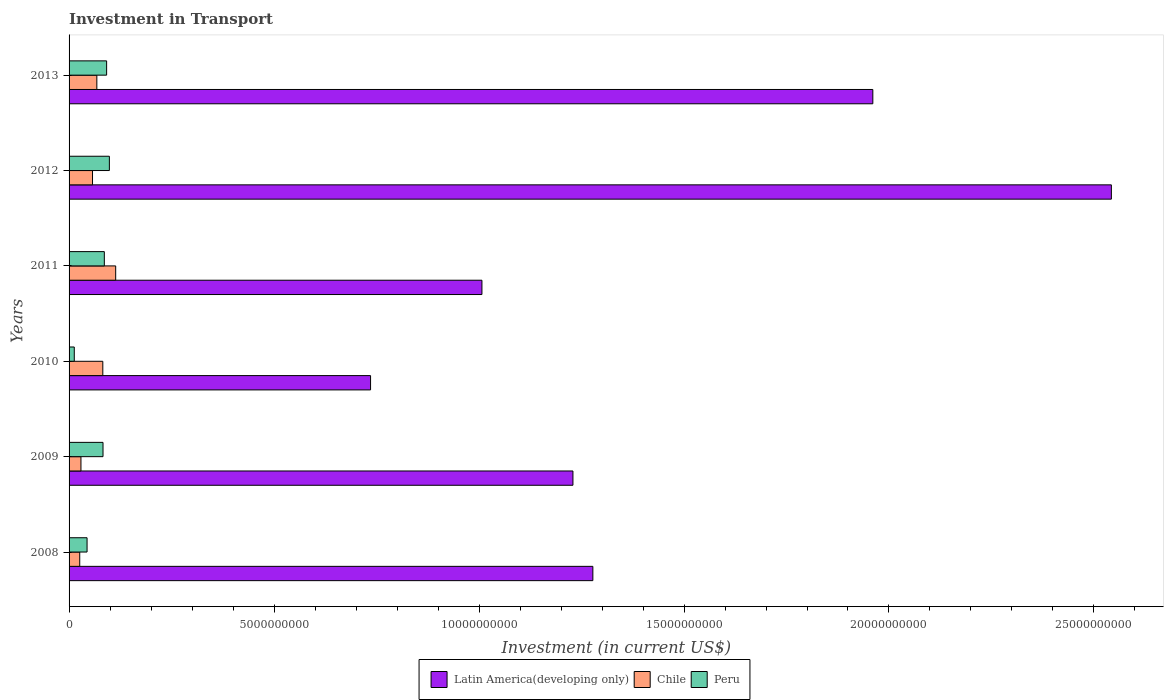How many different coloured bars are there?
Your response must be concise. 3. What is the label of the 4th group of bars from the top?
Your answer should be very brief. 2010. In how many cases, is the number of bars for a given year not equal to the number of legend labels?
Give a very brief answer. 0. What is the amount invested in transport in Peru in 2011?
Your answer should be very brief. 8.60e+08. Across all years, what is the maximum amount invested in transport in Latin America(developing only)?
Ensure brevity in your answer.  2.54e+1. Across all years, what is the minimum amount invested in transport in Latin America(developing only)?
Give a very brief answer. 7.35e+09. In which year was the amount invested in transport in Chile maximum?
Provide a short and direct response. 2011. What is the total amount invested in transport in Peru in the graph?
Your answer should be very brief. 4.15e+09. What is the difference between the amount invested in transport in Latin America(developing only) in 2010 and that in 2012?
Your answer should be very brief. -1.81e+1. What is the difference between the amount invested in transport in Latin America(developing only) in 2009 and the amount invested in transport in Chile in 2012?
Your answer should be compact. 1.17e+1. What is the average amount invested in transport in Latin America(developing only) per year?
Keep it short and to the point. 1.46e+1. In the year 2013, what is the difference between the amount invested in transport in Chile and amount invested in transport in Latin America(developing only)?
Your answer should be very brief. -1.89e+1. In how many years, is the amount invested in transport in Peru greater than 21000000000 US$?
Ensure brevity in your answer.  0. What is the ratio of the amount invested in transport in Peru in 2011 to that in 2012?
Your answer should be very brief. 0.87. Is the difference between the amount invested in transport in Chile in 2012 and 2013 greater than the difference between the amount invested in transport in Latin America(developing only) in 2012 and 2013?
Offer a terse response. No. What is the difference between the highest and the second highest amount invested in transport in Chile?
Your answer should be compact. 3.14e+08. What is the difference between the highest and the lowest amount invested in transport in Peru?
Your answer should be compact. 8.56e+08. In how many years, is the amount invested in transport in Peru greater than the average amount invested in transport in Peru taken over all years?
Your answer should be very brief. 4. Is the sum of the amount invested in transport in Latin America(developing only) in 2011 and 2013 greater than the maximum amount invested in transport in Peru across all years?
Provide a short and direct response. Yes. What does the 2nd bar from the bottom in 2011 represents?
Keep it short and to the point. Chile. How many bars are there?
Your answer should be very brief. 18. What is the difference between two consecutive major ticks on the X-axis?
Your answer should be compact. 5.00e+09. Where does the legend appear in the graph?
Provide a succinct answer. Bottom center. How many legend labels are there?
Ensure brevity in your answer.  3. How are the legend labels stacked?
Keep it short and to the point. Horizontal. What is the title of the graph?
Your answer should be compact. Investment in Transport. What is the label or title of the X-axis?
Offer a very short reply. Investment (in current US$). What is the label or title of the Y-axis?
Offer a very short reply. Years. What is the Investment (in current US$) in Latin America(developing only) in 2008?
Your answer should be very brief. 1.28e+1. What is the Investment (in current US$) of Chile in 2008?
Give a very brief answer. 2.60e+08. What is the Investment (in current US$) in Peru in 2008?
Ensure brevity in your answer.  4.39e+08. What is the Investment (in current US$) of Latin America(developing only) in 2009?
Your answer should be very brief. 1.23e+1. What is the Investment (in current US$) of Chile in 2009?
Ensure brevity in your answer.  2.90e+08. What is the Investment (in current US$) in Peru in 2009?
Provide a short and direct response. 8.28e+08. What is the Investment (in current US$) in Latin America(developing only) in 2010?
Offer a very short reply. 7.35e+09. What is the Investment (in current US$) of Chile in 2010?
Give a very brief answer. 8.23e+08. What is the Investment (in current US$) of Peru in 2010?
Make the answer very short. 1.27e+08. What is the Investment (in current US$) in Latin America(developing only) in 2011?
Provide a short and direct response. 1.01e+1. What is the Investment (in current US$) in Chile in 2011?
Ensure brevity in your answer.  1.14e+09. What is the Investment (in current US$) of Peru in 2011?
Give a very brief answer. 8.60e+08. What is the Investment (in current US$) of Latin America(developing only) in 2012?
Make the answer very short. 2.54e+1. What is the Investment (in current US$) of Chile in 2012?
Your response must be concise. 5.72e+08. What is the Investment (in current US$) in Peru in 2012?
Ensure brevity in your answer.  9.83e+08. What is the Investment (in current US$) of Latin America(developing only) in 2013?
Offer a very short reply. 1.96e+1. What is the Investment (in current US$) of Chile in 2013?
Your answer should be very brief. 6.78e+08. What is the Investment (in current US$) of Peru in 2013?
Your response must be concise. 9.16e+08. Across all years, what is the maximum Investment (in current US$) in Latin America(developing only)?
Your answer should be very brief. 2.54e+1. Across all years, what is the maximum Investment (in current US$) of Chile?
Provide a short and direct response. 1.14e+09. Across all years, what is the maximum Investment (in current US$) in Peru?
Make the answer very short. 9.83e+08. Across all years, what is the minimum Investment (in current US$) of Latin America(developing only)?
Keep it short and to the point. 7.35e+09. Across all years, what is the minimum Investment (in current US$) in Chile?
Make the answer very short. 2.60e+08. Across all years, what is the minimum Investment (in current US$) of Peru?
Give a very brief answer. 1.27e+08. What is the total Investment (in current US$) of Latin America(developing only) in the graph?
Provide a short and direct response. 8.75e+1. What is the total Investment (in current US$) in Chile in the graph?
Give a very brief answer. 3.76e+09. What is the total Investment (in current US$) of Peru in the graph?
Provide a short and direct response. 4.15e+09. What is the difference between the Investment (in current US$) of Latin America(developing only) in 2008 and that in 2009?
Provide a succinct answer. 4.86e+08. What is the difference between the Investment (in current US$) of Chile in 2008 and that in 2009?
Make the answer very short. -2.99e+07. What is the difference between the Investment (in current US$) of Peru in 2008 and that in 2009?
Your answer should be compact. -3.89e+08. What is the difference between the Investment (in current US$) of Latin America(developing only) in 2008 and that in 2010?
Make the answer very short. 5.42e+09. What is the difference between the Investment (in current US$) of Chile in 2008 and that in 2010?
Your answer should be very brief. -5.63e+08. What is the difference between the Investment (in current US$) in Peru in 2008 and that in 2010?
Provide a short and direct response. 3.12e+08. What is the difference between the Investment (in current US$) in Latin America(developing only) in 2008 and that in 2011?
Ensure brevity in your answer.  2.71e+09. What is the difference between the Investment (in current US$) in Chile in 2008 and that in 2011?
Keep it short and to the point. -8.77e+08. What is the difference between the Investment (in current US$) of Peru in 2008 and that in 2011?
Your response must be concise. -4.21e+08. What is the difference between the Investment (in current US$) in Latin America(developing only) in 2008 and that in 2012?
Make the answer very short. -1.26e+1. What is the difference between the Investment (in current US$) of Chile in 2008 and that in 2012?
Give a very brief answer. -3.12e+08. What is the difference between the Investment (in current US$) of Peru in 2008 and that in 2012?
Ensure brevity in your answer.  -5.44e+08. What is the difference between the Investment (in current US$) in Latin America(developing only) in 2008 and that in 2013?
Your response must be concise. -6.83e+09. What is the difference between the Investment (in current US$) in Chile in 2008 and that in 2013?
Offer a terse response. -4.18e+08. What is the difference between the Investment (in current US$) of Peru in 2008 and that in 2013?
Ensure brevity in your answer.  -4.77e+08. What is the difference between the Investment (in current US$) of Latin America(developing only) in 2009 and that in 2010?
Make the answer very short. 4.94e+09. What is the difference between the Investment (in current US$) of Chile in 2009 and that in 2010?
Ensure brevity in your answer.  -5.33e+08. What is the difference between the Investment (in current US$) of Peru in 2009 and that in 2010?
Offer a very short reply. 7.01e+08. What is the difference between the Investment (in current US$) of Latin America(developing only) in 2009 and that in 2011?
Your response must be concise. 2.22e+09. What is the difference between the Investment (in current US$) of Chile in 2009 and that in 2011?
Provide a short and direct response. -8.47e+08. What is the difference between the Investment (in current US$) of Peru in 2009 and that in 2011?
Keep it short and to the point. -3.22e+07. What is the difference between the Investment (in current US$) in Latin America(developing only) in 2009 and that in 2012?
Make the answer very short. -1.31e+1. What is the difference between the Investment (in current US$) of Chile in 2009 and that in 2012?
Offer a very short reply. -2.82e+08. What is the difference between the Investment (in current US$) of Peru in 2009 and that in 2012?
Offer a very short reply. -1.55e+08. What is the difference between the Investment (in current US$) in Latin America(developing only) in 2009 and that in 2013?
Keep it short and to the point. -7.32e+09. What is the difference between the Investment (in current US$) of Chile in 2009 and that in 2013?
Give a very brief answer. -3.88e+08. What is the difference between the Investment (in current US$) in Peru in 2009 and that in 2013?
Ensure brevity in your answer.  -8.82e+07. What is the difference between the Investment (in current US$) in Latin America(developing only) in 2010 and that in 2011?
Provide a short and direct response. -2.72e+09. What is the difference between the Investment (in current US$) of Chile in 2010 and that in 2011?
Give a very brief answer. -3.14e+08. What is the difference between the Investment (in current US$) in Peru in 2010 and that in 2011?
Make the answer very short. -7.33e+08. What is the difference between the Investment (in current US$) of Latin America(developing only) in 2010 and that in 2012?
Your response must be concise. -1.81e+1. What is the difference between the Investment (in current US$) of Chile in 2010 and that in 2012?
Ensure brevity in your answer.  2.51e+08. What is the difference between the Investment (in current US$) in Peru in 2010 and that in 2012?
Offer a terse response. -8.56e+08. What is the difference between the Investment (in current US$) in Latin America(developing only) in 2010 and that in 2013?
Make the answer very short. -1.23e+1. What is the difference between the Investment (in current US$) in Chile in 2010 and that in 2013?
Your answer should be compact. 1.45e+08. What is the difference between the Investment (in current US$) in Peru in 2010 and that in 2013?
Make the answer very short. -7.89e+08. What is the difference between the Investment (in current US$) of Latin America(developing only) in 2011 and that in 2012?
Provide a succinct answer. -1.54e+1. What is the difference between the Investment (in current US$) of Chile in 2011 and that in 2012?
Offer a terse response. 5.65e+08. What is the difference between the Investment (in current US$) of Peru in 2011 and that in 2012?
Provide a short and direct response. -1.23e+08. What is the difference between the Investment (in current US$) in Latin America(developing only) in 2011 and that in 2013?
Your answer should be very brief. -9.53e+09. What is the difference between the Investment (in current US$) of Chile in 2011 and that in 2013?
Keep it short and to the point. 4.59e+08. What is the difference between the Investment (in current US$) of Peru in 2011 and that in 2013?
Keep it short and to the point. -5.60e+07. What is the difference between the Investment (in current US$) of Latin America(developing only) in 2012 and that in 2013?
Provide a succinct answer. 5.82e+09. What is the difference between the Investment (in current US$) of Chile in 2012 and that in 2013?
Your response must be concise. -1.06e+08. What is the difference between the Investment (in current US$) of Peru in 2012 and that in 2013?
Your answer should be compact. 6.70e+07. What is the difference between the Investment (in current US$) of Latin America(developing only) in 2008 and the Investment (in current US$) of Chile in 2009?
Your answer should be very brief. 1.25e+1. What is the difference between the Investment (in current US$) in Latin America(developing only) in 2008 and the Investment (in current US$) in Peru in 2009?
Your answer should be compact. 1.19e+1. What is the difference between the Investment (in current US$) in Chile in 2008 and the Investment (in current US$) in Peru in 2009?
Your answer should be very brief. -5.68e+08. What is the difference between the Investment (in current US$) in Latin America(developing only) in 2008 and the Investment (in current US$) in Chile in 2010?
Offer a terse response. 1.20e+1. What is the difference between the Investment (in current US$) of Latin America(developing only) in 2008 and the Investment (in current US$) of Peru in 2010?
Ensure brevity in your answer.  1.26e+1. What is the difference between the Investment (in current US$) in Chile in 2008 and the Investment (in current US$) in Peru in 2010?
Offer a very short reply. 1.33e+08. What is the difference between the Investment (in current US$) in Latin America(developing only) in 2008 and the Investment (in current US$) in Chile in 2011?
Offer a very short reply. 1.16e+1. What is the difference between the Investment (in current US$) of Latin America(developing only) in 2008 and the Investment (in current US$) of Peru in 2011?
Keep it short and to the point. 1.19e+1. What is the difference between the Investment (in current US$) in Chile in 2008 and the Investment (in current US$) in Peru in 2011?
Make the answer very short. -6.00e+08. What is the difference between the Investment (in current US$) of Latin America(developing only) in 2008 and the Investment (in current US$) of Chile in 2012?
Give a very brief answer. 1.22e+1. What is the difference between the Investment (in current US$) of Latin America(developing only) in 2008 and the Investment (in current US$) of Peru in 2012?
Your answer should be compact. 1.18e+1. What is the difference between the Investment (in current US$) in Chile in 2008 and the Investment (in current US$) in Peru in 2012?
Your answer should be compact. -7.23e+08. What is the difference between the Investment (in current US$) of Latin America(developing only) in 2008 and the Investment (in current US$) of Chile in 2013?
Provide a succinct answer. 1.21e+1. What is the difference between the Investment (in current US$) of Latin America(developing only) in 2008 and the Investment (in current US$) of Peru in 2013?
Provide a short and direct response. 1.19e+1. What is the difference between the Investment (in current US$) in Chile in 2008 and the Investment (in current US$) in Peru in 2013?
Offer a very short reply. -6.56e+08. What is the difference between the Investment (in current US$) of Latin America(developing only) in 2009 and the Investment (in current US$) of Chile in 2010?
Offer a terse response. 1.15e+1. What is the difference between the Investment (in current US$) in Latin America(developing only) in 2009 and the Investment (in current US$) in Peru in 2010?
Ensure brevity in your answer.  1.22e+1. What is the difference between the Investment (in current US$) of Chile in 2009 and the Investment (in current US$) of Peru in 2010?
Provide a succinct answer. 1.63e+08. What is the difference between the Investment (in current US$) in Latin America(developing only) in 2009 and the Investment (in current US$) in Chile in 2011?
Give a very brief answer. 1.12e+1. What is the difference between the Investment (in current US$) in Latin America(developing only) in 2009 and the Investment (in current US$) in Peru in 2011?
Ensure brevity in your answer.  1.14e+1. What is the difference between the Investment (in current US$) of Chile in 2009 and the Investment (in current US$) of Peru in 2011?
Ensure brevity in your answer.  -5.70e+08. What is the difference between the Investment (in current US$) of Latin America(developing only) in 2009 and the Investment (in current US$) of Chile in 2012?
Make the answer very short. 1.17e+1. What is the difference between the Investment (in current US$) in Latin America(developing only) in 2009 and the Investment (in current US$) in Peru in 2012?
Provide a short and direct response. 1.13e+1. What is the difference between the Investment (in current US$) in Chile in 2009 and the Investment (in current US$) in Peru in 2012?
Your answer should be very brief. -6.93e+08. What is the difference between the Investment (in current US$) in Latin America(developing only) in 2009 and the Investment (in current US$) in Chile in 2013?
Your answer should be very brief. 1.16e+1. What is the difference between the Investment (in current US$) of Latin America(developing only) in 2009 and the Investment (in current US$) of Peru in 2013?
Ensure brevity in your answer.  1.14e+1. What is the difference between the Investment (in current US$) of Chile in 2009 and the Investment (in current US$) of Peru in 2013?
Keep it short and to the point. -6.26e+08. What is the difference between the Investment (in current US$) in Latin America(developing only) in 2010 and the Investment (in current US$) in Chile in 2011?
Provide a succinct answer. 6.22e+09. What is the difference between the Investment (in current US$) in Latin America(developing only) in 2010 and the Investment (in current US$) in Peru in 2011?
Make the answer very short. 6.49e+09. What is the difference between the Investment (in current US$) of Chile in 2010 and the Investment (in current US$) of Peru in 2011?
Your response must be concise. -3.70e+07. What is the difference between the Investment (in current US$) in Latin America(developing only) in 2010 and the Investment (in current US$) in Chile in 2012?
Make the answer very short. 6.78e+09. What is the difference between the Investment (in current US$) in Latin America(developing only) in 2010 and the Investment (in current US$) in Peru in 2012?
Provide a short and direct response. 6.37e+09. What is the difference between the Investment (in current US$) of Chile in 2010 and the Investment (in current US$) of Peru in 2012?
Ensure brevity in your answer.  -1.60e+08. What is the difference between the Investment (in current US$) in Latin America(developing only) in 2010 and the Investment (in current US$) in Chile in 2013?
Your answer should be compact. 6.68e+09. What is the difference between the Investment (in current US$) in Latin America(developing only) in 2010 and the Investment (in current US$) in Peru in 2013?
Offer a very short reply. 6.44e+09. What is the difference between the Investment (in current US$) in Chile in 2010 and the Investment (in current US$) in Peru in 2013?
Provide a succinct answer. -9.30e+07. What is the difference between the Investment (in current US$) of Latin America(developing only) in 2011 and the Investment (in current US$) of Chile in 2012?
Keep it short and to the point. 9.50e+09. What is the difference between the Investment (in current US$) of Latin America(developing only) in 2011 and the Investment (in current US$) of Peru in 2012?
Your answer should be compact. 9.09e+09. What is the difference between the Investment (in current US$) in Chile in 2011 and the Investment (in current US$) in Peru in 2012?
Ensure brevity in your answer.  1.54e+08. What is the difference between the Investment (in current US$) of Latin America(developing only) in 2011 and the Investment (in current US$) of Chile in 2013?
Offer a terse response. 9.39e+09. What is the difference between the Investment (in current US$) of Latin America(developing only) in 2011 and the Investment (in current US$) of Peru in 2013?
Give a very brief answer. 9.16e+09. What is the difference between the Investment (in current US$) of Chile in 2011 and the Investment (in current US$) of Peru in 2013?
Give a very brief answer. 2.21e+08. What is the difference between the Investment (in current US$) of Latin America(developing only) in 2012 and the Investment (in current US$) of Chile in 2013?
Keep it short and to the point. 2.47e+1. What is the difference between the Investment (in current US$) of Latin America(developing only) in 2012 and the Investment (in current US$) of Peru in 2013?
Your answer should be very brief. 2.45e+1. What is the difference between the Investment (in current US$) in Chile in 2012 and the Investment (in current US$) in Peru in 2013?
Your answer should be compact. -3.44e+08. What is the average Investment (in current US$) in Latin America(developing only) per year?
Offer a terse response. 1.46e+1. What is the average Investment (in current US$) of Chile per year?
Offer a terse response. 6.27e+08. What is the average Investment (in current US$) in Peru per year?
Your answer should be compact. 6.92e+08. In the year 2008, what is the difference between the Investment (in current US$) of Latin America(developing only) and Investment (in current US$) of Chile?
Your answer should be compact. 1.25e+1. In the year 2008, what is the difference between the Investment (in current US$) in Latin America(developing only) and Investment (in current US$) in Peru?
Your answer should be compact. 1.23e+1. In the year 2008, what is the difference between the Investment (in current US$) in Chile and Investment (in current US$) in Peru?
Give a very brief answer. -1.79e+08. In the year 2009, what is the difference between the Investment (in current US$) of Latin America(developing only) and Investment (in current US$) of Chile?
Provide a short and direct response. 1.20e+1. In the year 2009, what is the difference between the Investment (in current US$) in Latin America(developing only) and Investment (in current US$) in Peru?
Offer a very short reply. 1.15e+1. In the year 2009, what is the difference between the Investment (in current US$) of Chile and Investment (in current US$) of Peru?
Offer a very short reply. -5.38e+08. In the year 2010, what is the difference between the Investment (in current US$) in Latin America(developing only) and Investment (in current US$) in Chile?
Keep it short and to the point. 6.53e+09. In the year 2010, what is the difference between the Investment (in current US$) of Latin America(developing only) and Investment (in current US$) of Peru?
Offer a very short reply. 7.23e+09. In the year 2010, what is the difference between the Investment (in current US$) in Chile and Investment (in current US$) in Peru?
Ensure brevity in your answer.  6.96e+08. In the year 2011, what is the difference between the Investment (in current US$) in Latin America(developing only) and Investment (in current US$) in Chile?
Provide a short and direct response. 8.93e+09. In the year 2011, what is the difference between the Investment (in current US$) of Latin America(developing only) and Investment (in current US$) of Peru?
Give a very brief answer. 9.21e+09. In the year 2011, what is the difference between the Investment (in current US$) of Chile and Investment (in current US$) of Peru?
Provide a succinct answer. 2.77e+08. In the year 2012, what is the difference between the Investment (in current US$) of Latin America(developing only) and Investment (in current US$) of Chile?
Your answer should be compact. 2.49e+1. In the year 2012, what is the difference between the Investment (in current US$) of Latin America(developing only) and Investment (in current US$) of Peru?
Keep it short and to the point. 2.44e+1. In the year 2012, what is the difference between the Investment (in current US$) of Chile and Investment (in current US$) of Peru?
Your answer should be compact. -4.11e+08. In the year 2013, what is the difference between the Investment (in current US$) of Latin America(developing only) and Investment (in current US$) of Chile?
Provide a succinct answer. 1.89e+1. In the year 2013, what is the difference between the Investment (in current US$) of Latin America(developing only) and Investment (in current US$) of Peru?
Provide a succinct answer. 1.87e+1. In the year 2013, what is the difference between the Investment (in current US$) in Chile and Investment (in current US$) in Peru?
Your answer should be very brief. -2.38e+08. What is the ratio of the Investment (in current US$) of Latin America(developing only) in 2008 to that in 2009?
Your answer should be compact. 1.04. What is the ratio of the Investment (in current US$) of Chile in 2008 to that in 2009?
Ensure brevity in your answer.  0.9. What is the ratio of the Investment (in current US$) in Peru in 2008 to that in 2009?
Your answer should be very brief. 0.53. What is the ratio of the Investment (in current US$) of Latin America(developing only) in 2008 to that in 2010?
Ensure brevity in your answer.  1.74. What is the ratio of the Investment (in current US$) of Chile in 2008 to that in 2010?
Your answer should be very brief. 0.32. What is the ratio of the Investment (in current US$) of Peru in 2008 to that in 2010?
Provide a succinct answer. 3.46. What is the ratio of the Investment (in current US$) in Latin America(developing only) in 2008 to that in 2011?
Keep it short and to the point. 1.27. What is the ratio of the Investment (in current US$) in Chile in 2008 to that in 2011?
Offer a very short reply. 0.23. What is the ratio of the Investment (in current US$) in Peru in 2008 to that in 2011?
Your response must be concise. 0.51. What is the ratio of the Investment (in current US$) of Latin America(developing only) in 2008 to that in 2012?
Your answer should be compact. 0.5. What is the ratio of the Investment (in current US$) of Chile in 2008 to that in 2012?
Your answer should be compact. 0.46. What is the ratio of the Investment (in current US$) in Peru in 2008 to that in 2012?
Your response must be concise. 0.45. What is the ratio of the Investment (in current US$) of Latin America(developing only) in 2008 to that in 2013?
Provide a succinct answer. 0.65. What is the ratio of the Investment (in current US$) in Chile in 2008 to that in 2013?
Provide a short and direct response. 0.38. What is the ratio of the Investment (in current US$) of Peru in 2008 to that in 2013?
Keep it short and to the point. 0.48. What is the ratio of the Investment (in current US$) in Latin America(developing only) in 2009 to that in 2010?
Your response must be concise. 1.67. What is the ratio of the Investment (in current US$) of Chile in 2009 to that in 2010?
Offer a terse response. 0.35. What is the ratio of the Investment (in current US$) in Peru in 2009 to that in 2010?
Offer a very short reply. 6.52. What is the ratio of the Investment (in current US$) of Latin America(developing only) in 2009 to that in 2011?
Make the answer very short. 1.22. What is the ratio of the Investment (in current US$) in Chile in 2009 to that in 2011?
Provide a succinct answer. 0.26. What is the ratio of the Investment (in current US$) of Peru in 2009 to that in 2011?
Ensure brevity in your answer.  0.96. What is the ratio of the Investment (in current US$) in Latin America(developing only) in 2009 to that in 2012?
Provide a succinct answer. 0.48. What is the ratio of the Investment (in current US$) in Chile in 2009 to that in 2012?
Offer a terse response. 0.51. What is the ratio of the Investment (in current US$) in Peru in 2009 to that in 2012?
Give a very brief answer. 0.84. What is the ratio of the Investment (in current US$) of Latin America(developing only) in 2009 to that in 2013?
Offer a terse response. 0.63. What is the ratio of the Investment (in current US$) in Chile in 2009 to that in 2013?
Make the answer very short. 0.43. What is the ratio of the Investment (in current US$) in Peru in 2009 to that in 2013?
Ensure brevity in your answer.  0.9. What is the ratio of the Investment (in current US$) in Latin America(developing only) in 2010 to that in 2011?
Offer a very short reply. 0.73. What is the ratio of the Investment (in current US$) in Chile in 2010 to that in 2011?
Your response must be concise. 0.72. What is the ratio of the Investment (in current US$) in Peru in 2010 to that in 2011?
Keep it short and to the point. 0.15. What is the ratio of the Investment (in current US$) in Latin America(developing only) in 2010 to that in 2012?
Make the answer very short. 0.29. What is the ratio of the Investment (in current US$) of Chile in 2010 to that in 2012?
Make the answer very short. 1.44. What is the ratio of the Investment (in current US$) of Peru in 2010 to that in 2012?
Make the answer very short. 0.13. What is the ratio of the Investment (in current US$) of Latin America(developing only) in 2010 to that in 2013?
Give a very brief answer. 0.38. What is the ratio of the Investment (in current US$) in Chile in 2010 to that in 2013?
Your response must be concise. 1.21. What is the ratio of the Investment (in current US$) in Peru in 2010 to that in 2013?
Give a very brief answer. 0.14. What is the ratio of the Investment (in current US$) of Latin America(developing only) in 2011 to that in 2012?
Your answer should be compact. 0.4. What is the ratio of the Investment (in current US$) of Chile in 2011 to that in 2012?
Give a very brief answer. 1.99. What is the ratio of the Investment (in current US$) in Peru in 2011 to that in 2012?
Your response must be concise. 0.87. What is the ratio of the Investment (in current US$) in Latin America(developing only) in 2011 to that in 2013?
Provide a short and direct response. 0.51. What is the ratio of the Investment (in current US$) of Chile in 2011 to that in 2013?
Offer a terse response. 1.68. What is the ratio of the Investment (in current US$) of Peru in 2011 to that in 2013?
Your answer should be compact. 0.94. What is the ratio of the Investment (in current US$) in Latin America(developing only) in 2012 to that in 2013?
Keep it short and to the point. 1.3. What is the ratio of the Investment (in current US$) of Chile in 2012 to that in 2013?
Ensure brevity in your answer.  0.84. What is the ratio of the Investment (in current US$) in Peru in 2012 to that in 2013?
Ensure brevity in your answer.  1.07. What is the difference between the highest and the second highest Investment (in current US$) of Latin America(developing only)?
Provide a succinct answer. 5.82e+09. What is the difference between the highest and the second highest Investment (in current US$) in Chile?
Give a very brief answer. 3.14e+08. What is the difference between the highest and the second highest Investment (in current US$) of Peru?
Your response must be concise. 6.70e+07. What is the difference between the highest and the lowest Investment (in current US$) of Latin America(developing only)?
Offer a very short reply. 1.81e+1. What is the difference between the highest and the lowest Investment (in current US$) in Chile?
Keep it short and to the point. 8.77e+08. What is the difference between the highest and the lowest Investment (in current US$) of Peru?
Ensure brevity in your answer.  8.56e+08. 